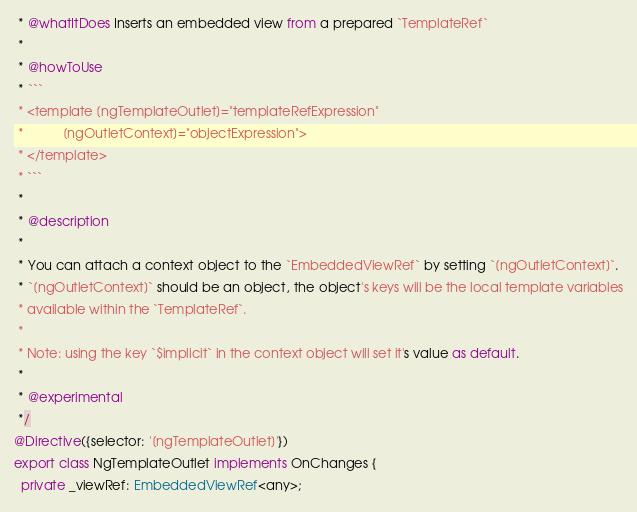<code> <loc_0><loc_0><loc_500><loc_500><_TypeScript_> * @whatItDoes Inserts an embedded view from a prepared `TemplateRef`
 *
 * @howToUse
 * ```
 * <template [ngTemplateOutlet]="templateRefExpression"
 *           [ngOutletContext]="objectExpression">
 * </template>
 * ```
 *
 * @description
 *
 * You can attach a context object to the `EmbeddedViewRef` by setting `[ngOutletContext]`.
 * `[ngOutletContext]` should be an object, the object's keys will be the local template variables
 * available within the `TemplateRef`.
 *
 * Note: using the key `$implicit` in the context object will set it's value as default.
 *
 * @experimental
 */
@Directive({selector: '[ngTemplateOutlet]'})
export class NgTemplateOutlet implements OnChanges {
  private _viewRef: EmbeddedViewRef<any>;</code> 